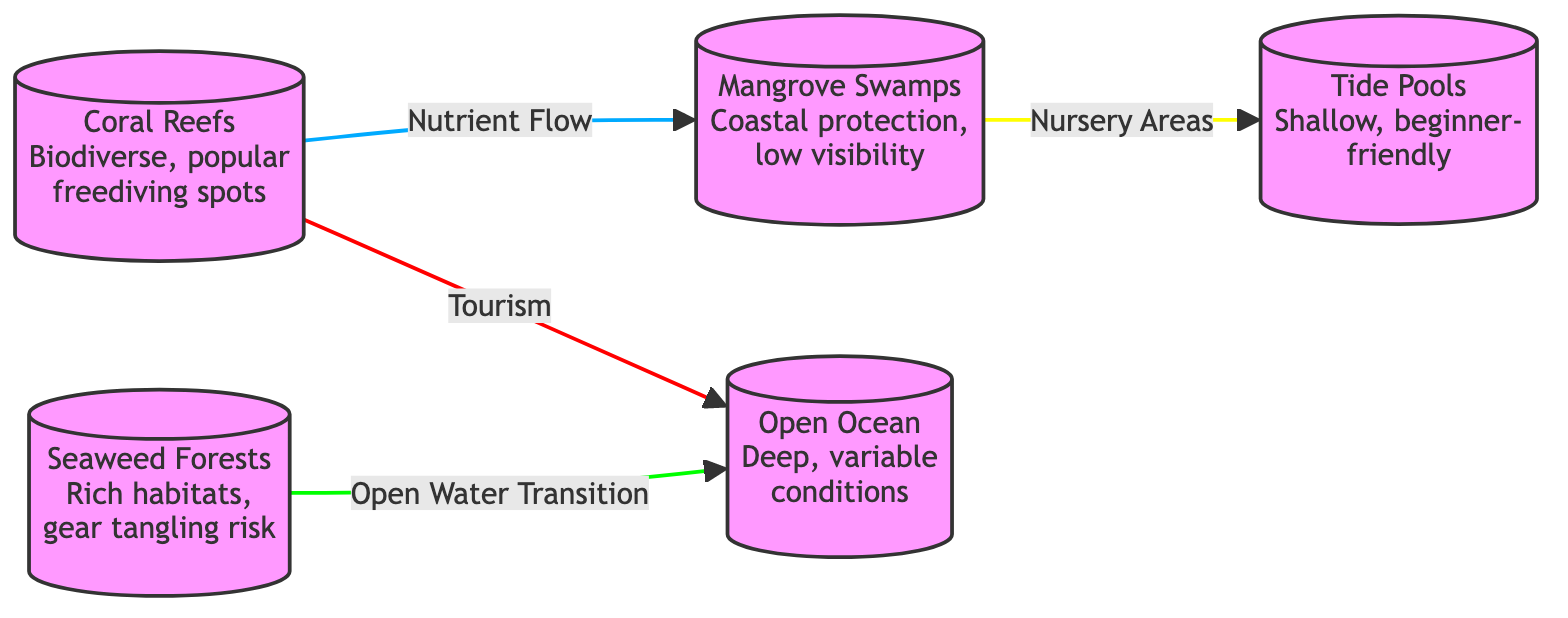What are the five ecosystems depicted in the diagram? The diagram displays five nodes representing different ecosystems: Coral Reefs, Seaweed Forests, Mangrove Swamps, Open Ocean, and Tide Pools.
Answer: Coral Reefs, Seaweed Forests, Mangrove Swamps, Open Ocean, Tide Pools How many edges are present in the diagram? The diagram has four edges that represent relationships between the ecosystems: Nutrient Flow, Open Water Transition, Tourism, and Nursery Areas.
Answer: Four What does the "Open Water Transition" edge connect? The "Open Water Transition" edge connects Seaweed Forests to Open Ocean, indicating a transition zone for divers moving from shallower habitats to deeper waters.
Answer: Seaweed Forests to Open Ocean Which ecosystem provides nursery areas for juvenile marine life? Mangrove Swamps are identified as providing nursery areas, offering protection for juvenile marine life before they move into more open waters like tide pools.
Answer: Mangrove Swamps What type of visibility is often associated with Mangrove Swamps? The description of Mangrove Swamps mentions that they typically have low visibility underwater, which can affect diving conditions.
Answer: Low visibility What relationship exists between Coral Reefs and Mangrove Swamps? The relationship labeled "Nutrient Flow" indicates that nutrients from Mangrove Swamps support and enhance the health of Coral Reefs.
Answer: Nutrient Flow Why are Coral Reefs and Open Ocean both popular for freediving? Both ecosystems are popular tourism destinations for freedivers, but they offer different experiences due to their varying conditions; coral reefs are shallower and more biodiverse, while the open ocean is deeper and offers variable conditions.
Answer: Tourism How do Tide Pools relate to Mangrove Swamps? The edge labeled "Nursery Areas" connects Mangrove Swamps to Tide Pools, suggesting that the mangroves help protect nursery habitats that enhance survivability for young marine organisms found in the tide pools.
Answer: Nursery Areas 